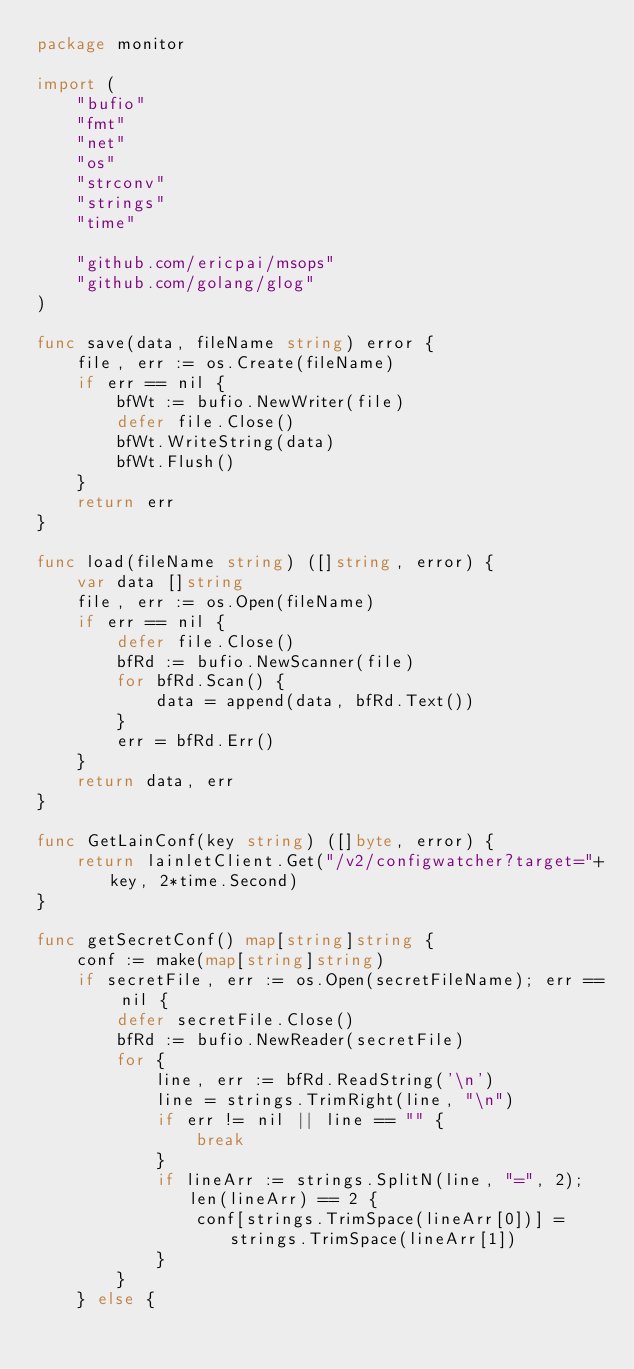Convert code to text. <code><loc_0><loc_0><loc_500><loc_500><_Go_>package monitor

import (
	"bufio"
	"fmt"
	"net"
	"os"
	"strconv"
	"strings"
	"time"

	"github.com/ericpai/msops"
	"github.com/golang/glog"
)

func save(data, fileName string) error {
	file, err := os.Create(fileName)
	if err == nil {
		bfWt := bufio.NewWriter(file)
		defer file.Close()
		bfWt.WriteString(data)
		bfWt.Flush()
	}
	return err
}

func load(fileName string) ([]string, error) {
	var data []string
	file, err := os.Open(fileName)
	if err == nil {
		defer file.Close()
		bfRd := bufio.NewScanner(file)
		for bfRd.Scan() {
			data = append(data, bfRd.Text())
		}
		err = bfRd.Err()
	}
	return data, err
}

func GetLainConf(key string) ([]byte, error) {
	return lainletClient.Get("/v2/configwatcher?target="+key, 2*time.Second)
}

func getSecretConf() map[string]string {
	conf := make(map[string]string)
	if secretFile, err := os.Open(secretFileName); err == nil {
		defer secretFile.Close()
		bfRd := bufio.NewReader(secretFile)
		for {
			line, err := bfRd.ReadString('\n')
			line = strings.TrimRight(line, "\n")
			if err != nil || line == "" {
				break
			}
			if lineArr := strings.SplitN(line, "=", 2); len(lineArr) == 2 {
				conf[strings.TrimSpace(lineArr[0])] = strings.TrimSpace(lineArr[1])
			}
		}
	} else {</code> 